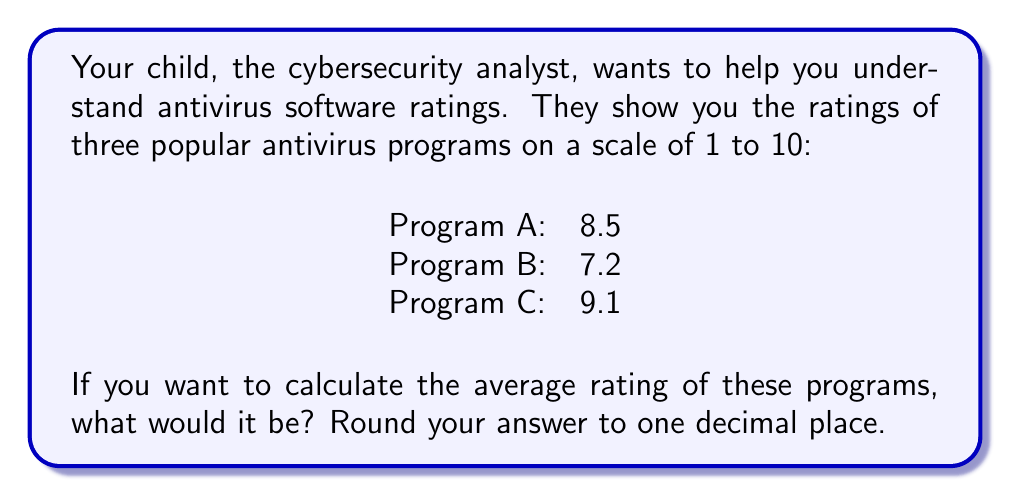Provide a solution to this math problem. To find the average rating of the antivirus programs, we need to:

1. Add up all the ratings
2. Divide the sum by the number of programs

Let's break it down step-by-step:

1. Sum of ratings:
   $$ 8.5 + 7.2 + 9.1 = 24.8 $$

2. Number of programs: 3

3. Calculate the average:
   $$ \text{Average} = \frac{\text{Sum of ratings}}{\text{Number of programs}} = \frac{24.8}{3} = 8.2666... $$

4. Round to one decimal place:
   $8.2666...$ rounds to $8.3$

This average gives us a general idea of how these antivirus programs perform overall, making it easier to compare them as a group to other options.
Answer: $8.3$ 